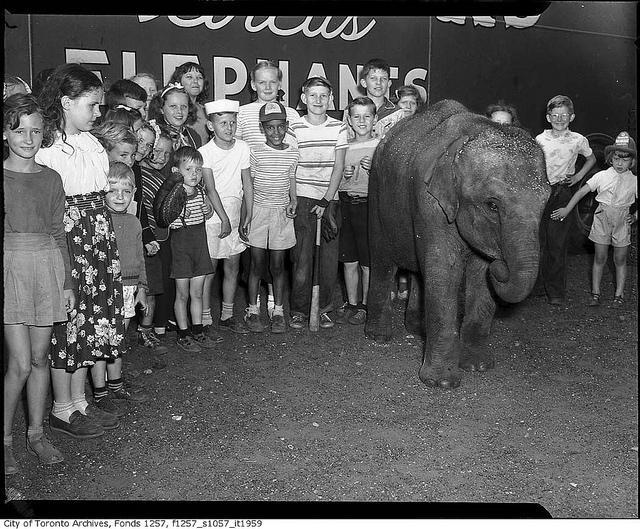How many people are standing next to each other?
Answer briefly. 23. How many animals are in the picture?
Give a very brief answer. 1. What type of hat is the boy on the far right wearing?
Quick response, please. Fireman. Does this look like an airport?
Quick response, please. No. 